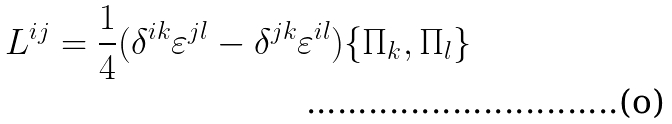Convert formula to latex. <formula><loc_0><loc_0><loc_500><loc_500>L ^ { i j } = \frac { 1 } { 4 } ( \delta ^ { i k } \varepsilon ^ { j l } - \delta ^ { j k } \varepsilon ^ { i l } ) \{ \Pi _ { k } , \Pi _ { l } \}</formula> 